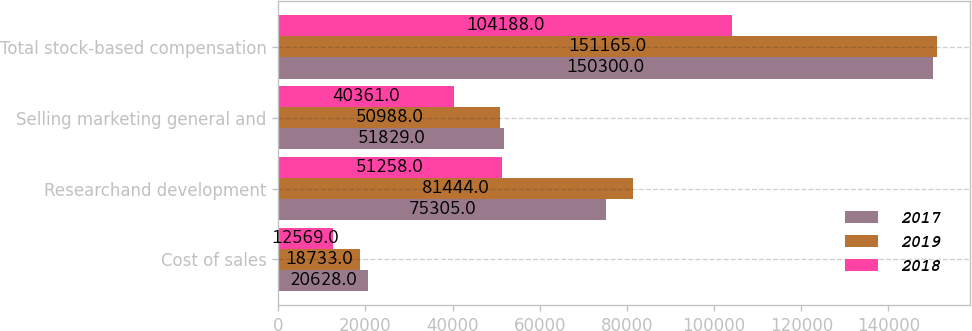<chart> <loc_0><loc_0><loc_500><loc_500><stacked_bar_chart><ecel><fcel>Cost of sales<fcel>Researchand development<fcel>Selling marketing general and<fcel>Total stock-based compensation<nl><fcel>2017<fcel>20628<fcel>75305<fcel>51829<fcel>150300<nl><fcel>2019<fcel>18733<fcel>81444<fcel>50988<fcel>151165<nl><fcel>2018<fcel>12569<fcel>51258<fcel>40361<fcel>104188<nl></chart> 